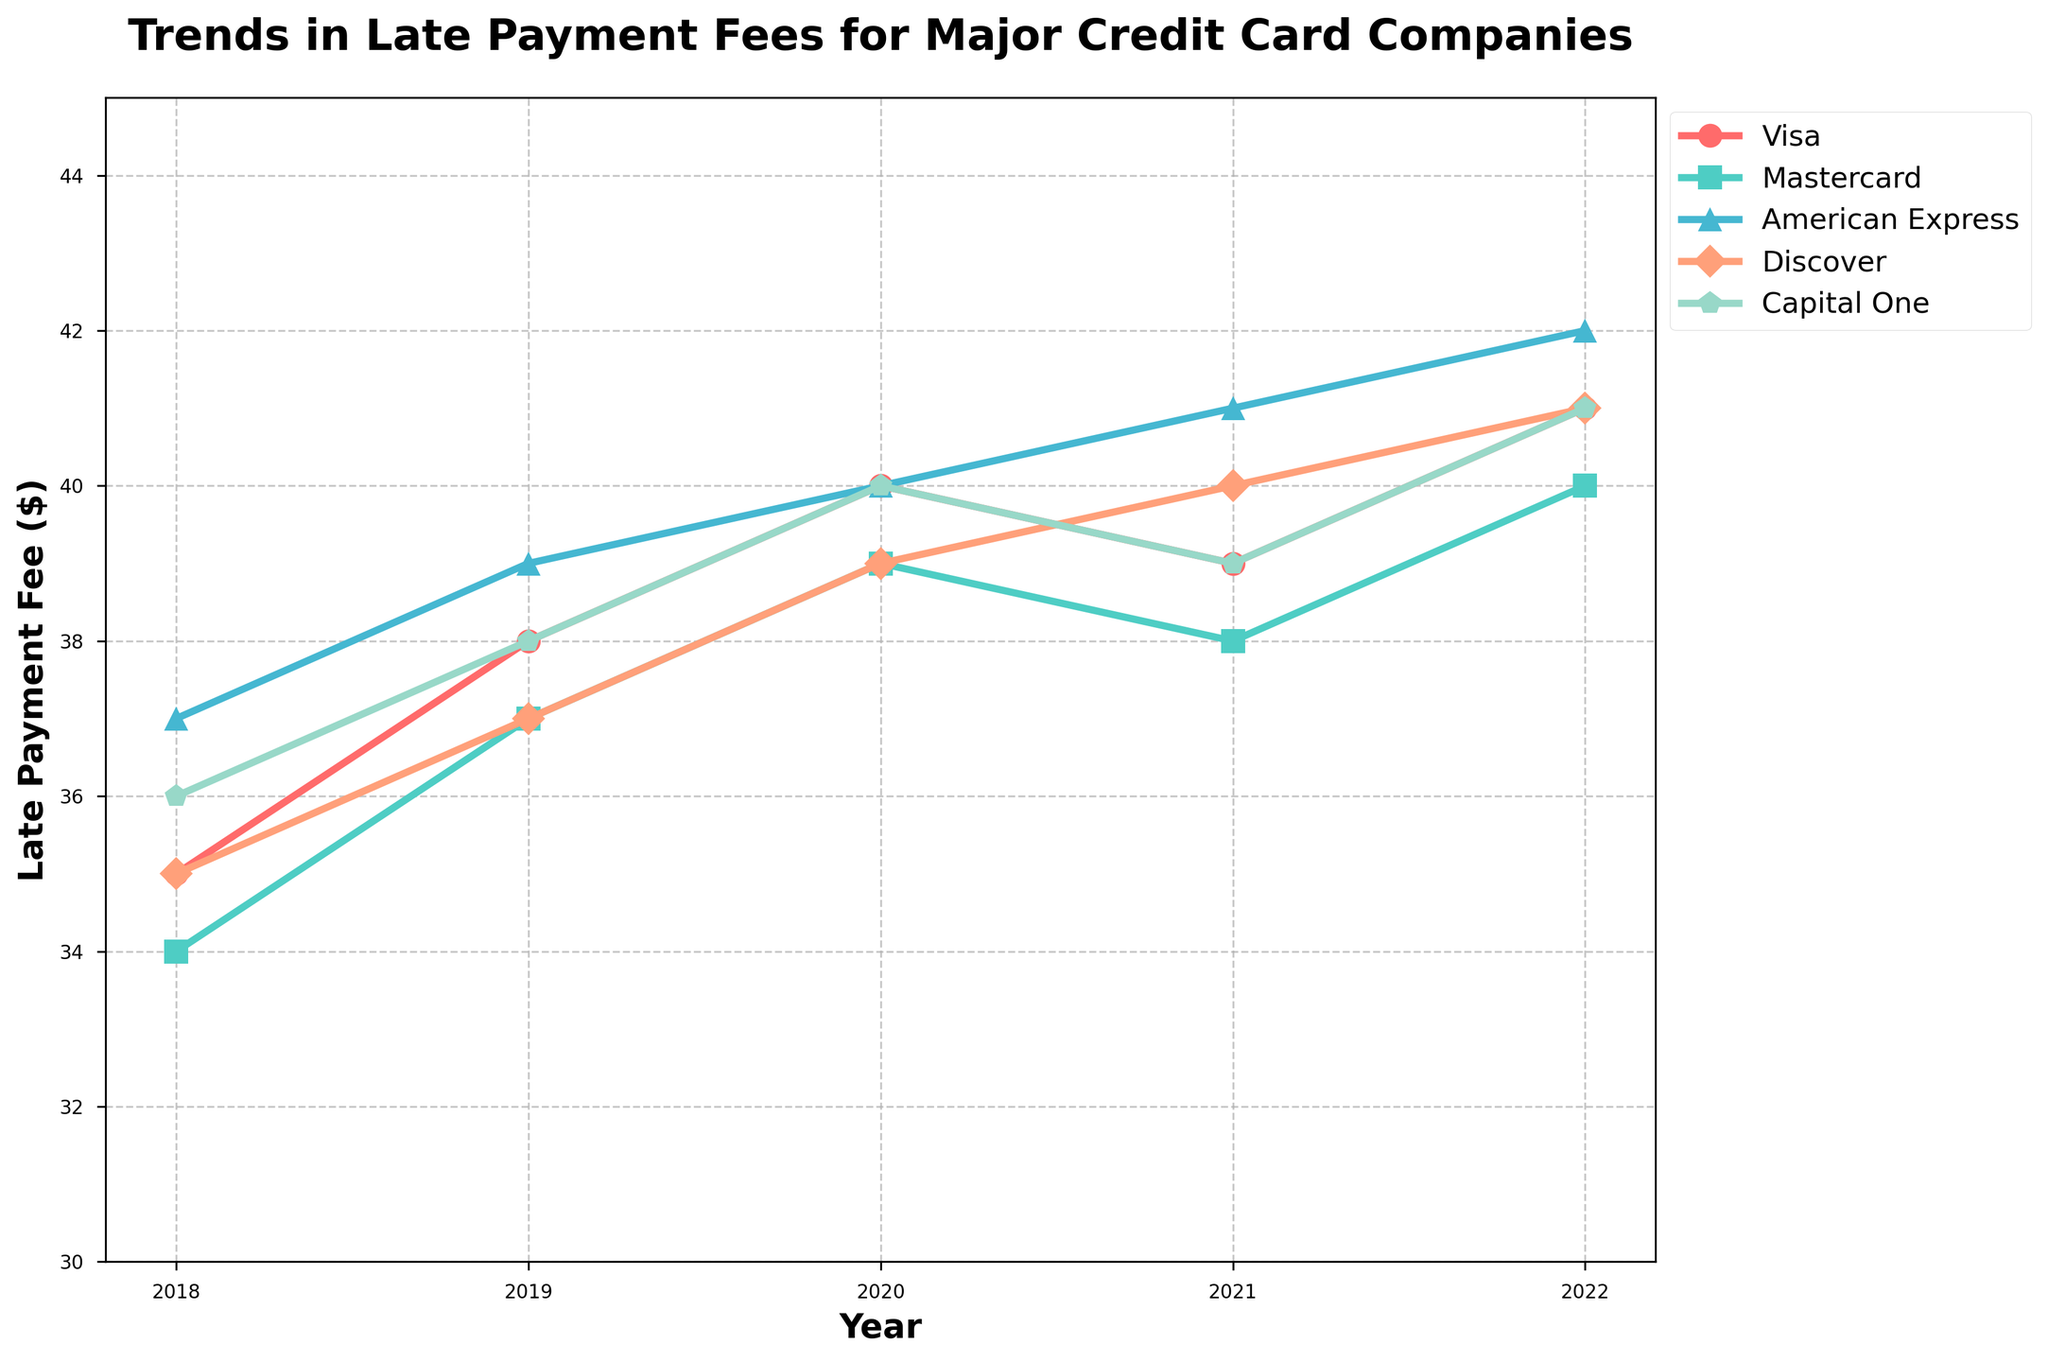How has the late payment fee for Visa changed from 2018 to 2022? To determine the change in the late payment fee for Visa from 2018 to 2022, we find the difference between the values in these years. In 2018, the fee was $35, and in 2022, it was $41. The change is $41 - $35.
Answer: $6 increase Which credit card company had the highest late payment fee in 2022? In 2022, the late payment fees are as follows: Visa and Capital One ($41), Mastercard ($40), American Express ($42), and Discover ($41). The highest fee is $42 from American Express.
Answer: American Express Between 2019 and 2020, which company's late payment fee increased the most? By comparing the values for each company from 2019 to 2020: Visa ($38 to $40, increase of $2), Mastercard ($37 to $39, increase of $2), American Express ($39 to $40, increase of $1), Discover ($37 to $39, increase of $2), and Capital One ($38 to $40, increase of $2). No single company increased more than the others; Visa, Mastercard, Discover, and Capital One all increased by $2.
Answer: Visa, Mastercard, Discover, and Capital One Which company showed the most consistent increase in late payment fees over the five years? To find the most consistent increase, we observe the trend lines: Visa increased each year with increments of 3, 2, -1, and 2; Mastercard increased by 3, 2, -1, and 2; American Express increased every year by 2, 1, 1, and 1; Discover increased by 2 each year then 1 each; and Capital One fluctuated but overall increased. American Express shows the most consistent increase.
Answer: American Express In which year was the average late payment fee across all companies the highest? Calculate the average fees per year: 
- 2018: (35+34+37+35+36) / 5 = 35.4
- 2019: (38+37+39+37+38) / 5 = 37.8
- 2020: (40+39+40+39+40) / 5 = 39.6
- 2021: (39+38+41+40+39) / 5 = 39.4
- 2022: (41+40+42+41+41) / 5 = 41.0
The highest average fee is in 2022.
Answer: 2022 What is the overall trend observed for Discover's late payment fees from 2018 to 2022? Let's trace Discover's fees over the years: 2018 ($35), 2019 ($37), 2020 ($39), 2021 ($40), 2022 ($41). The fee increases every year.
Answer: Increasing Which company had the smallest change in late payment fees from start to end of the 5-year period? Find the fee changes: 
- Visa: $41 - $35 = $6
- Mastercard: $40 - $34 = $6
- American Express: $42 - $37 = $5
- Discover: $41 - $35 = $6
- Capital One: $41 - $36 = $5
Both American Express and Capital One have the smallest change.
Answer: American Express and Capital One What is the total sum of late payment fees for Mastercard over the 5 years? Sum the values for Mastercard from 2018 to 2022: 34 + 37 + 39 + 38 + 40 = 188
Answer: 188 Has Capital One ever had the highest late payment fee among all companies in any year? Compare Capital One's fees to others each year:
- 2018: Capital One ($36); American Express ($37) highest
- 2019: Capital One ($38); American Express ($39) highest
- 2020: Capital One ($40); American Express ($40) highest
- 2021: Capital One ($39); American Express ($41) highest
- 2022: Capital One ($41); American Express ($42) highest
Capital One has never had the highest fee in any year.
Answer: No 